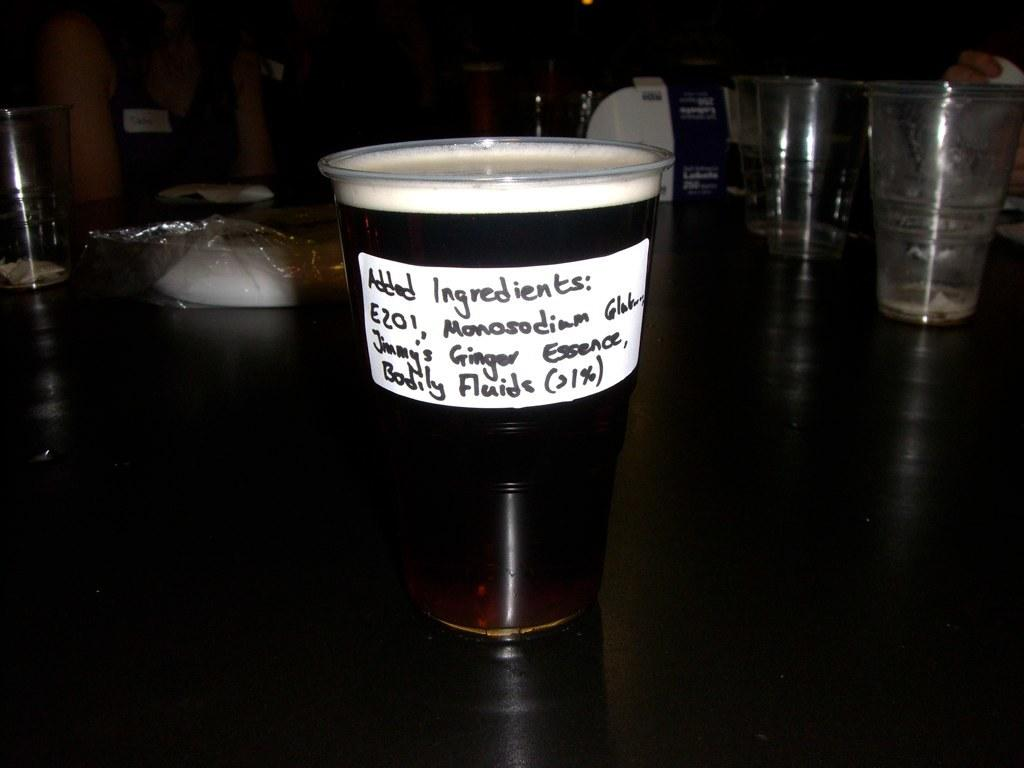<image>
Share a concise interpretation of the image provided. A glass full of what appears beer with foam has a label of added ingredients. 